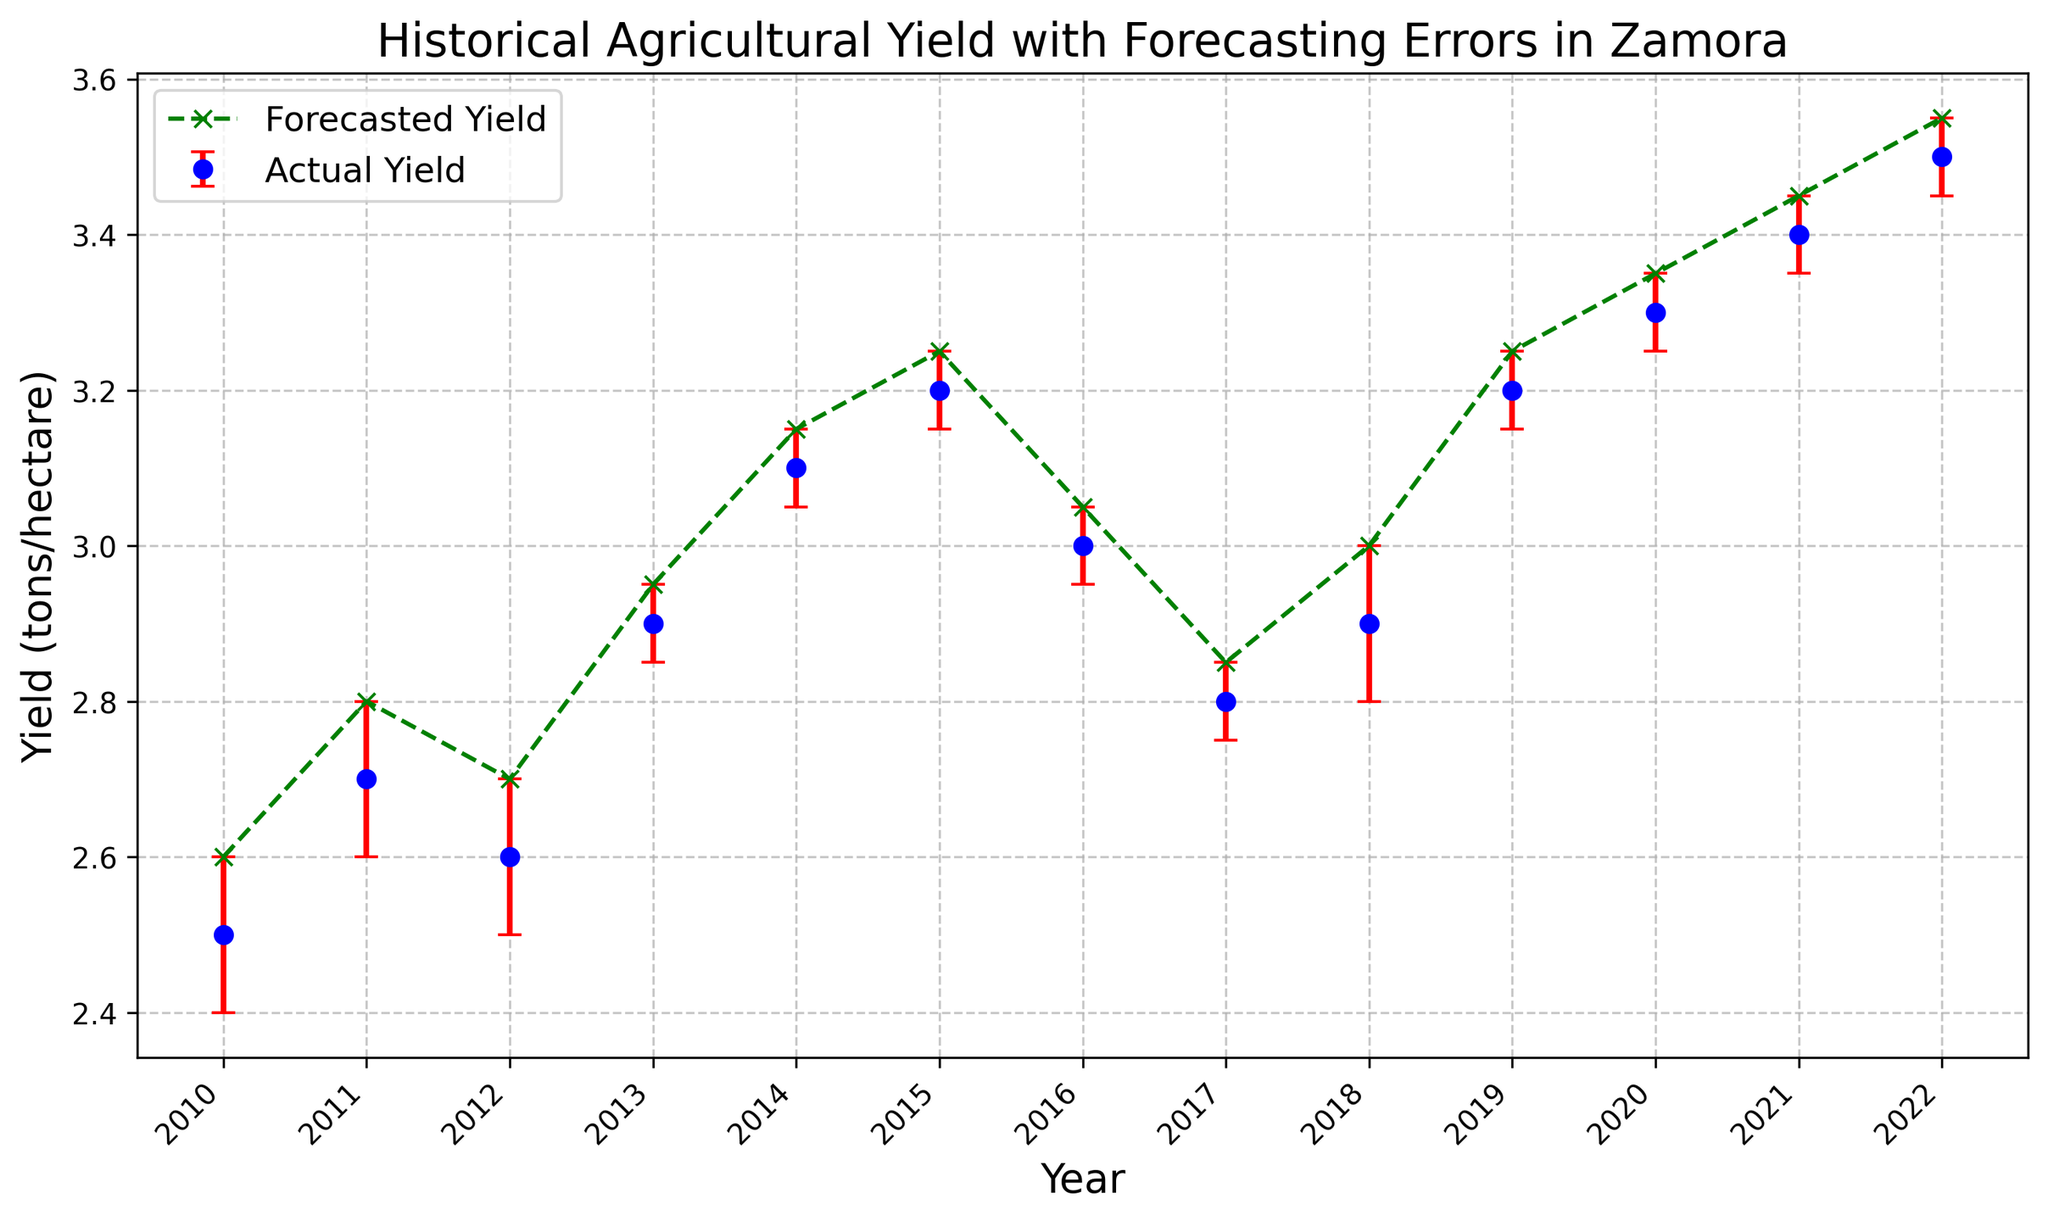What's the difference between the actual yield and forecasted yield in 2019? The actual yield in 2019 is 3.2 tons/hectare, while the forecasted yield is 3.25 tons/hectare. The difference is 3.25 - 3.2 = 0.05 tons/hectare.
Answer: 0.05 tons/hectare Which year shows the highest actual yield and what is its value? By viewing the actual yield data points, 2022 has the highest yield at 3.5 tons/hectare.
Answer: 2022, 3.5 tons/hectare How did the actual yield change from 2018 to 2019? The actual yield in 2018 is 2.9 tons/hectare, and in 2019, it is 3.2 tons/hectare. The change is 3.2 - 2.9 = 0.3 tons/hectare.
Answer: Increased by 0.3 tons/hectare Compare the forecasting error in 2012 and 2013. Which year had a lower error, and what is the difference? The forecasting error in 2012 is 0.1, and in 2013 it is 0.05. The difference is 0.1 - 0.05 = 0.05. 2013 had a lower error.
Answer: 2013, difference is 0.05 What is the average actual yield from 2010 to 2015? Summing the actual yields from 2010 to 2015: (2.5 + 2.7 + 2.6 + 2.9 + 3.1 + 3.2) = 17. Summing the number of years: 6. The average actual yield is 17 / 6 = 2.83 tons/hectare.
Answer: 2.83 tons/hectare Which years have a forecasted yield greater than 3 tons/hectare? By inspecting the forecasted yield values, the years with greater than 3 tons/hectare are: 2014, 2015, 2019, 2020, 2021, and 2022.
Answer: 2014, 2015, 2019, 2020, 2021, 2022 What is the overall trend of the actual yield from 2010 to 2022? Viewing the actual yield data from 2010 (2.5 tons/hectare) to 2022 (3.5 tons/hectare) shows a general increasing trend.
Answer: Increasing trend How many years have an actual yield less than or equal to 2.9 tons/hectare? The years with an actual yield of 2.9 tons/hectare or less are: 2010, 2011, 2012, 2013, 2017. This totals to 5 years.
Answer: 5 years Describe the visual difference between actual yield and forecasted yield lines. The actual yield is represented by blue circular markers with red error bars, while the forecasted yield is shown with green dashed lines and x markers.
Answer: Blue circles with red error bars vs. green dashed lines with x markers In which year was the forecasting error the highest? The forecasting error is indicated by the red error bars. The highest error is 0.1, which occurs in 2010, 2011, 2012, and 2018.
Answer: 2010, 2011, 2012, 2018 